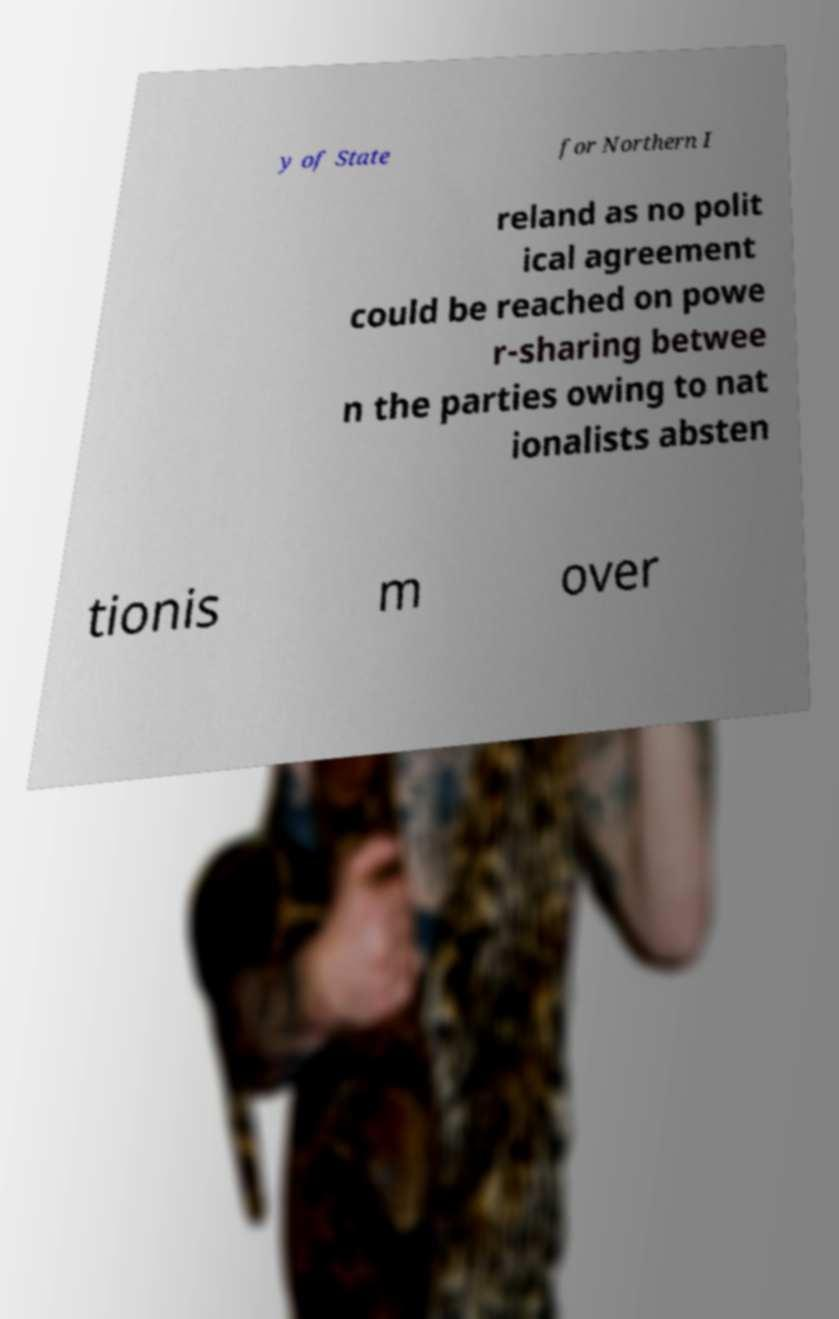I need the written content from this picture converted into text. Can you do that? y of State for Northern I reland as no polit ical agreement could be reached on powe r-sharing betwee n the parties owing to nat ionalists absten tionis m over 